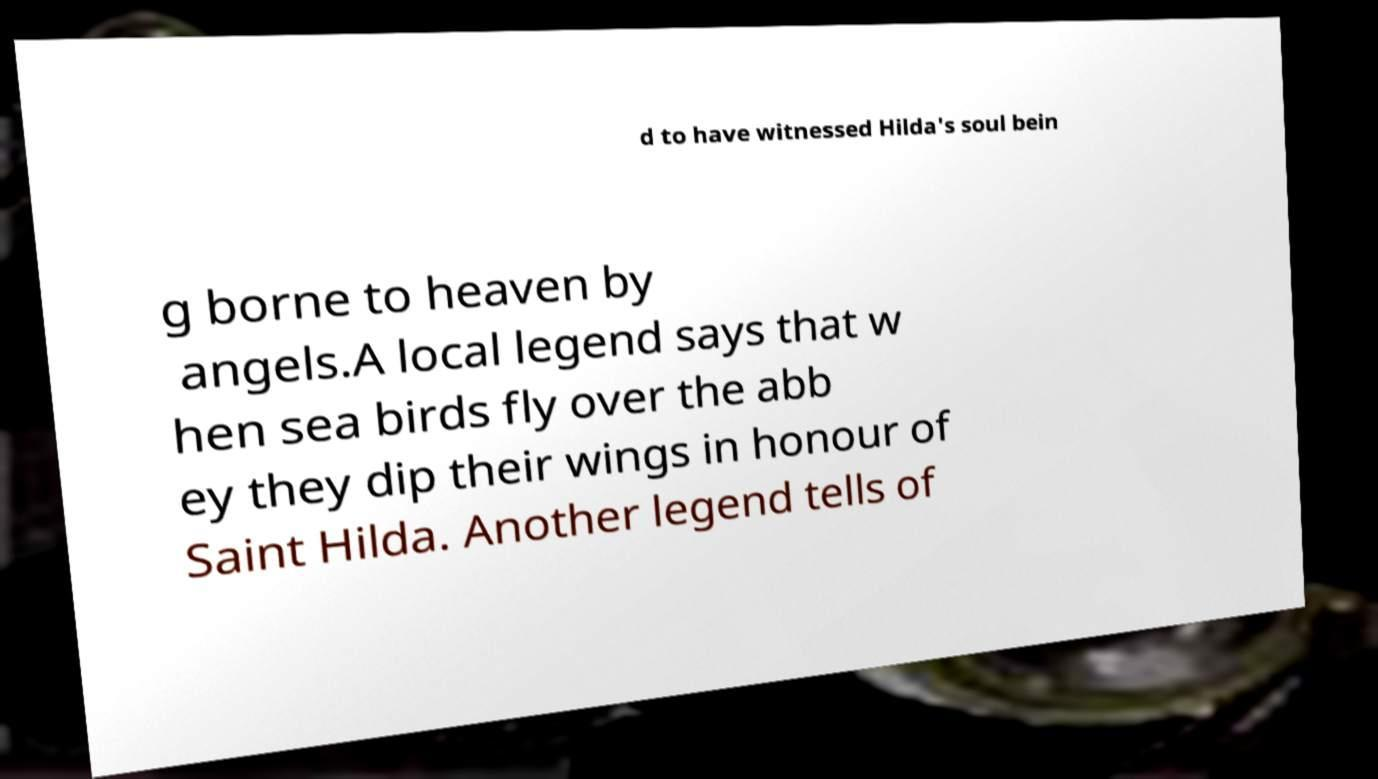What messages or text are displayed in this image? I need them in a readable, typed format. d to have witnessed Hilda's soul bein g borne to heaven by angels.A local legend says that w hen sea birds fly over the abb ey they dip their wings in honour of Saint Hilda. Another legend tells of 